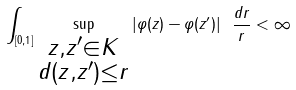Convert formula to latex. <formula><loc_0><loc_0><loc_500><loc_500>\int _ { [ 0 , 1 ] } \sup _ { \substack { z , z ^ { \prime } \in K \\ d ( z , z ^ { \prime } ) \leq r } } | \varphi ( z ) - \varphi ( z ^ { \prime } ) | \ \frac { d r } { r } < \infty</formula> 